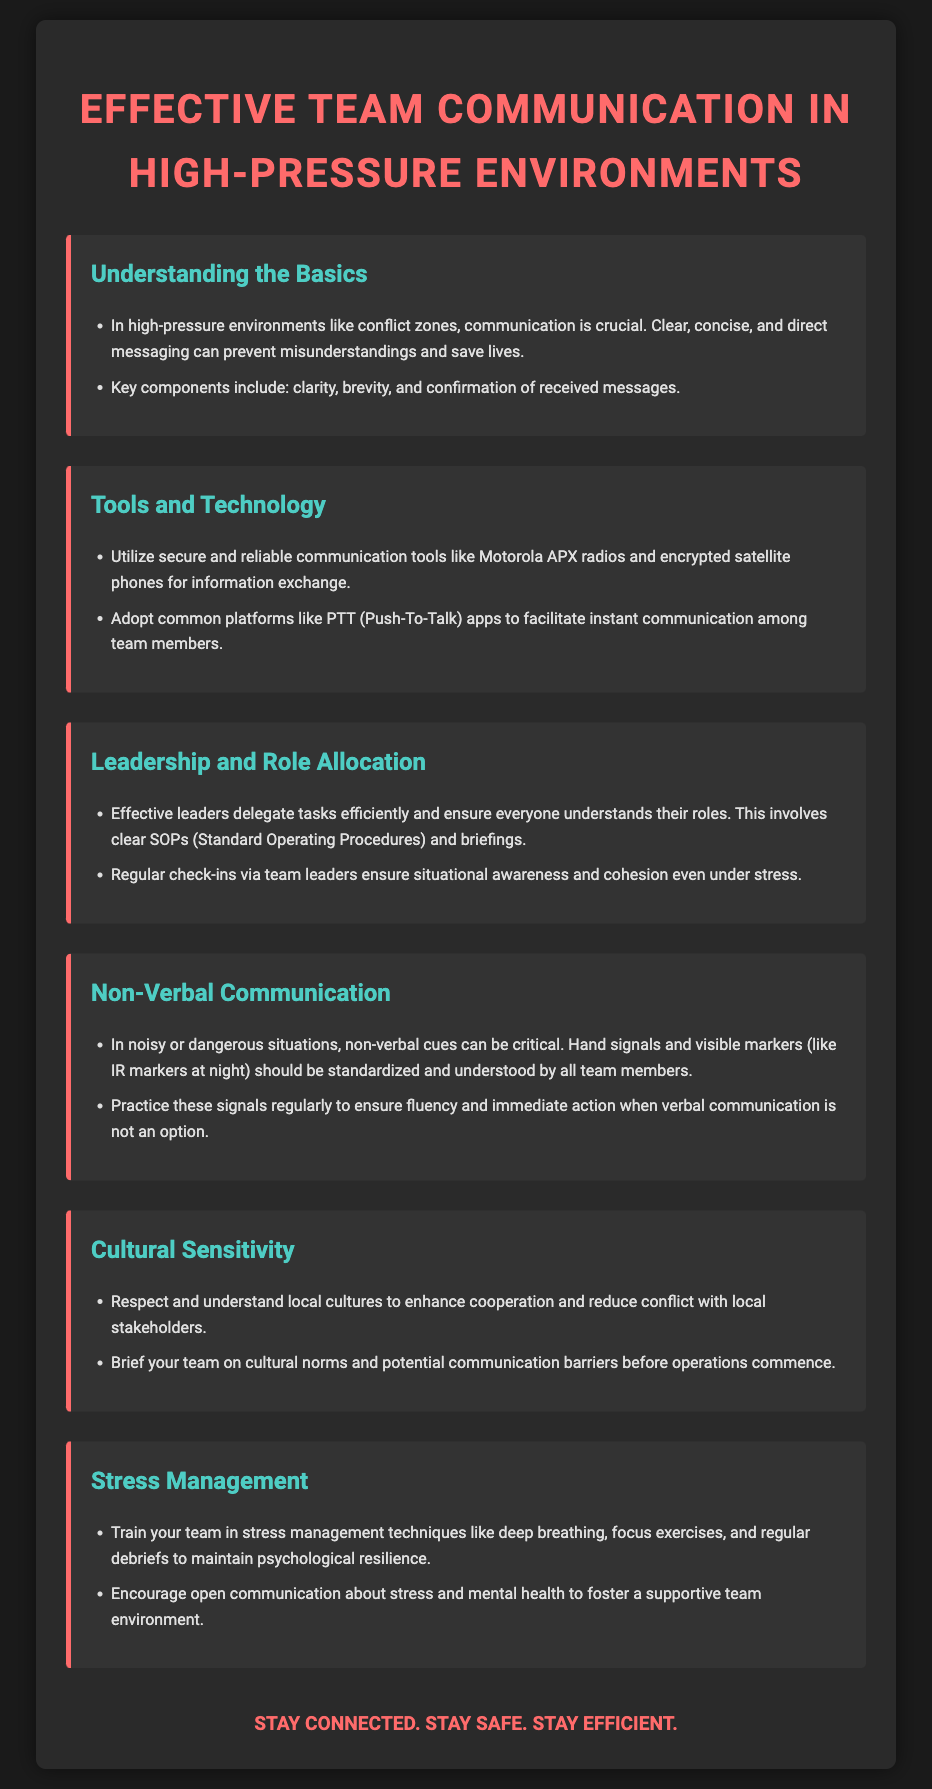what are the key components of effective communication? The document lists key components of effective communication as clarity, brevity, and confirmation of received messages.
Answer: clarity, brevity, and confirmation which tools are recommended for communication in conflict zones? The document suggests using secure and reliable communication tools such as Motorola APX radios and encrypted satellite phones.
Answer: Motorola APX radios and encrypted satellite phones what should leaders ensure for effective communication? Leaders should ensure everyone understands their roles and involve clear SOPs (Standard Operating Procedures) and briefings.
Answer: clear SOPs and briefings what is a non-verbal communication method mentioned? The document mentions hand signals and visible markers (like IR markers at night) as non-verbal communication methods.
Answer: hand signals and visible markers how can teams manage stress effectively? Training in stress management techniques like deep breathing and regular debriefs is recommended to maintain psychological resilience.
Answer: deep breathing and regular debriefs what is the purpose of cultural sensitivity in operations? Cultural sensitivity is aimed at enhancing cooperation and reducing conflict with local stakeholders.
Answer: enhancing cooperation and reducing conflict how should teams deal with communication barriers? The document advises briefing teams on cultural norms and potential communication barriers before operations commence.
Answer: briefing teams on cultural norms what type of apps are suggested for instant communication? The document recommends adopting common platforms like PTT (Push-To-Talk) apps for instant communication.
Answer: PTT apps why is confirmation of messages important in high-pressure environments? Confirmation of messages is crucial to prevent misunderstandings that can save lives in high-pressure environments.
Answer: to prevent misunderstandings 